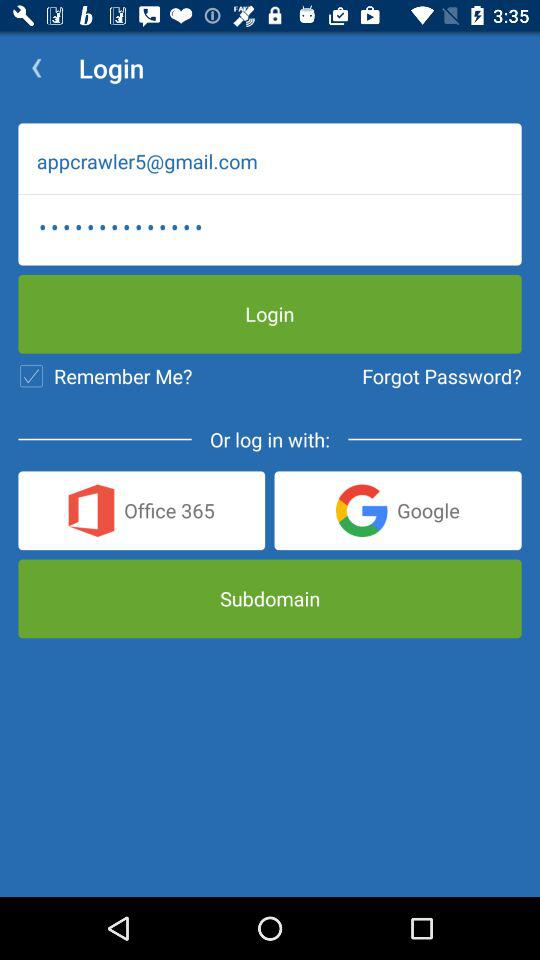What is the email ID of the user? The email ID of the user is appcrawler5@gmail.com. 